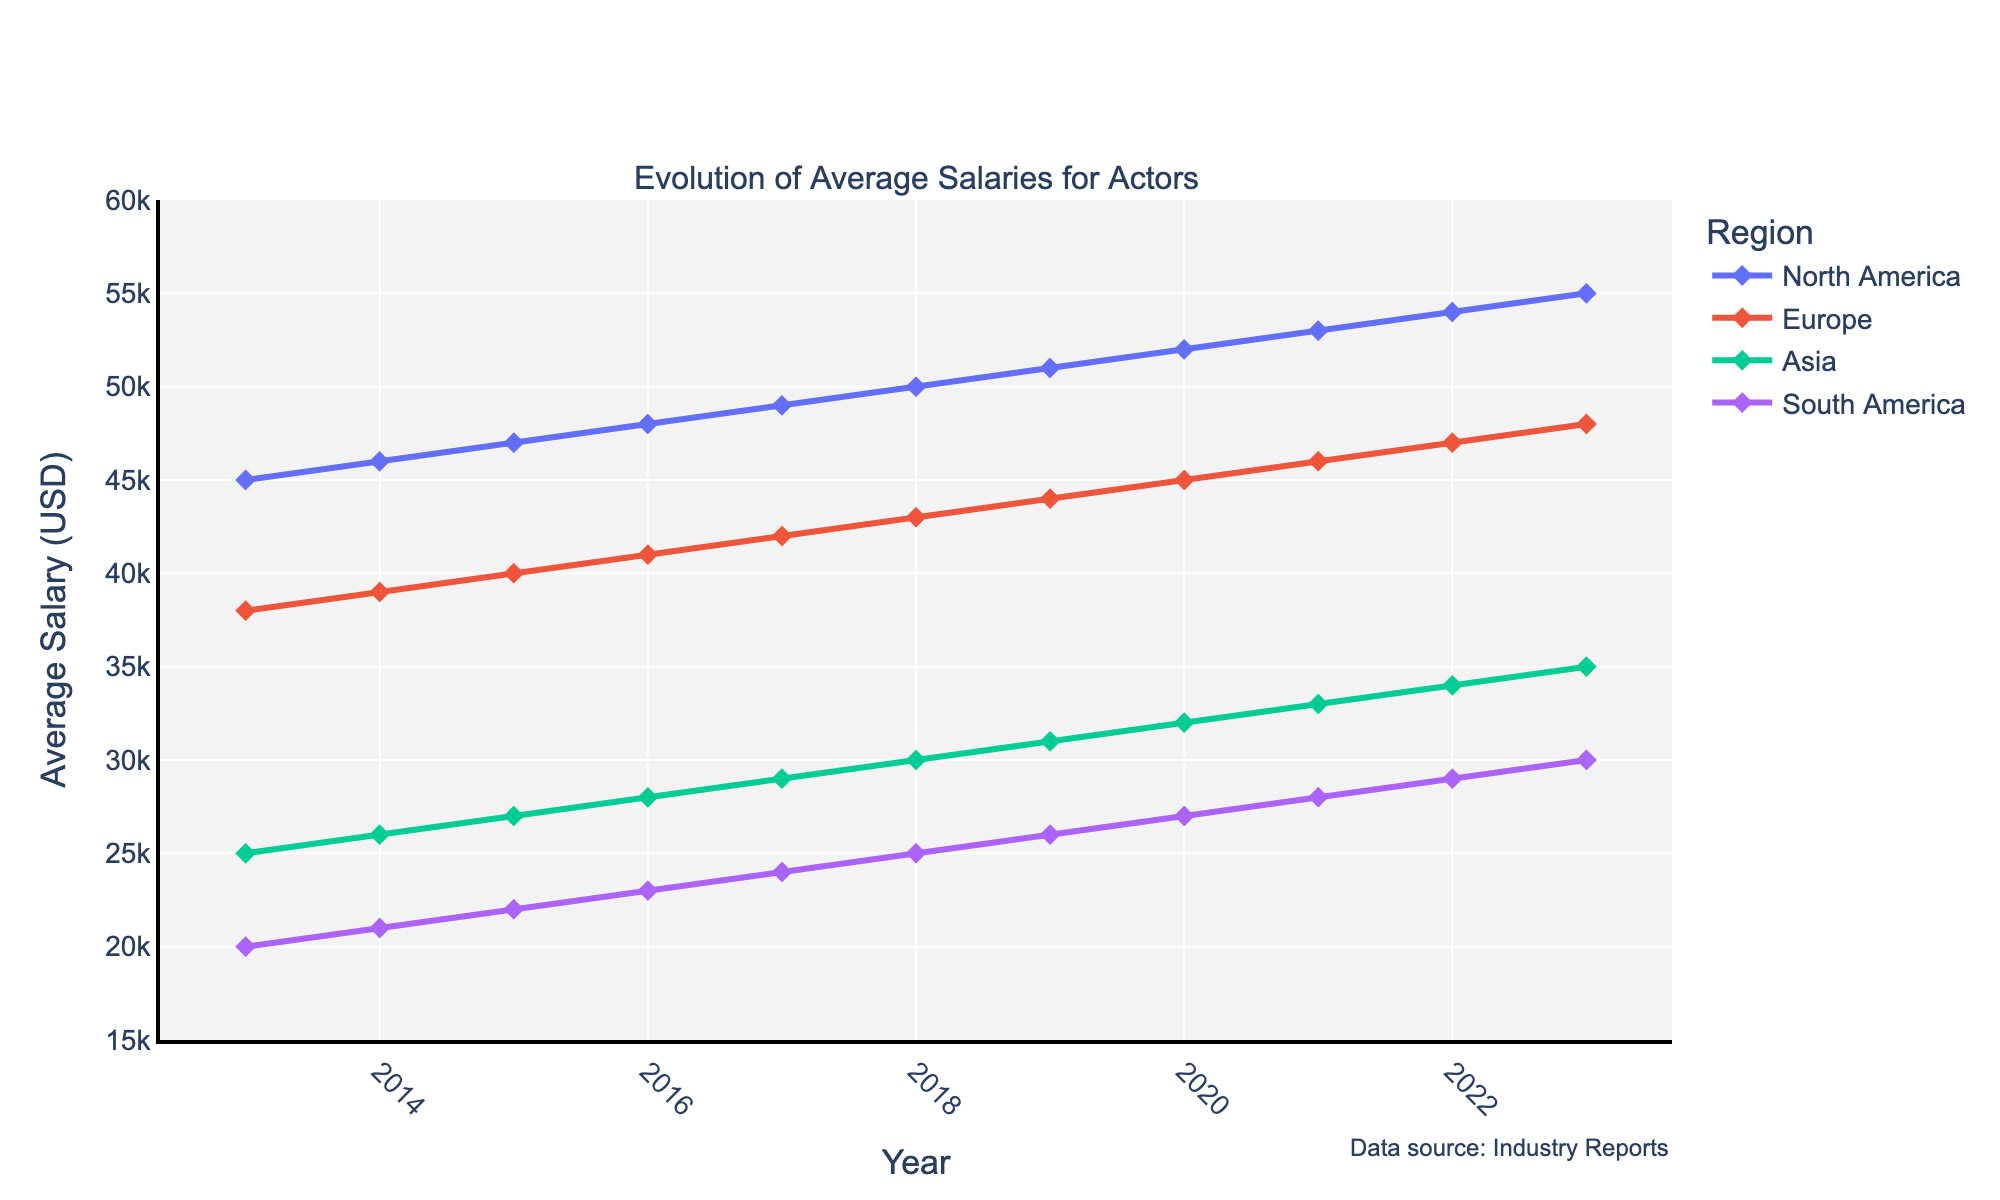What's the title of the figure? The title is usually placed at the top of a plot and serves as a summary of what the figure is about. In this case, the "subplot_titles" argument indicates the title, "Evolution of Average Salaries for Actors."
Answer: Evolution of Average Salaries for Actors Which region had the highest average salary for actors in 2023? To find this, look at the year 2023 on the x-axis and identify the highest point among the y-axis values representing the average salaries for different regions. North America reaches $55,000 in 2023.
Answer: North America What is the average salary for actors in Europe in 2018? Locate the year 2018 on the x-axis and check the corresponding y-axis value for Europe, which is marked by the line and markers specific to Europe. The salary is $43,000.
Answer: $43,000 By how much did the average salary for actors in Asia increase from 2013 to 2023? Subtract the 2013 value from the 2023 value for Asia. Asia's salary in 2013 was $25,000, and in 2023, it was $35,000. Hence, the increase is $35,000 - $25,000 = $10,000.
Answer: $10,000 What is the difference in average salaries between North America and South America in 2023? Identify the values for both regions in 2023. North America's average salary is $55,000, and South America's is $30,000. Subtract the two values: $55,000 - $30,000 = $25,000.
Answer: $25,000 Which region showed the most consistent year-to-year increase in average salaries over the last decade? Evaluate the slopes of the lines for each region from 2013 to 2023. North America and Europe show consistent increases, but North America appears more linear.
Answer: North America How many distinct regions are displayed in the figure? Count the unique labeled lines representing different regions on the plot. There are four: North America, Europe, Asia, and South America.
Answer: Four What is the approximate average increase in salary per year for actors in Europe from 2013 to 2023? Calculate the total increase by subtracting the 2013 salary from the 2023 salary, then divide by the number of years (2023 - 2013 = 10 years). Europe’s salaries increased from $38,000 to $48,000, so the increase is $48,000 - $38,000 = $10,000 over 10 years, or $10,000 / 10 = $1,000 per year.
Answer: $1,000 per year Between which two consecutive years did North America see its largest salary increase, and what was the increase? To find this, compare the year-to-year salary increases for North America. The largest increase can be found between 2022 ($54,000) and 2023 ($55,000), which is $55,000 - $54,000 = $1,000.
Answer: 2022 to 2023, $1,000 